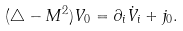Convert formula to latex. <formula><loc_0><loc_0><loc_500><loc_500>( \triangle - M ^ { 2 } ) V _ { 0 } = \partial _ { i } \dot { V } _ { i } + j _ { 0 } .</formula> 